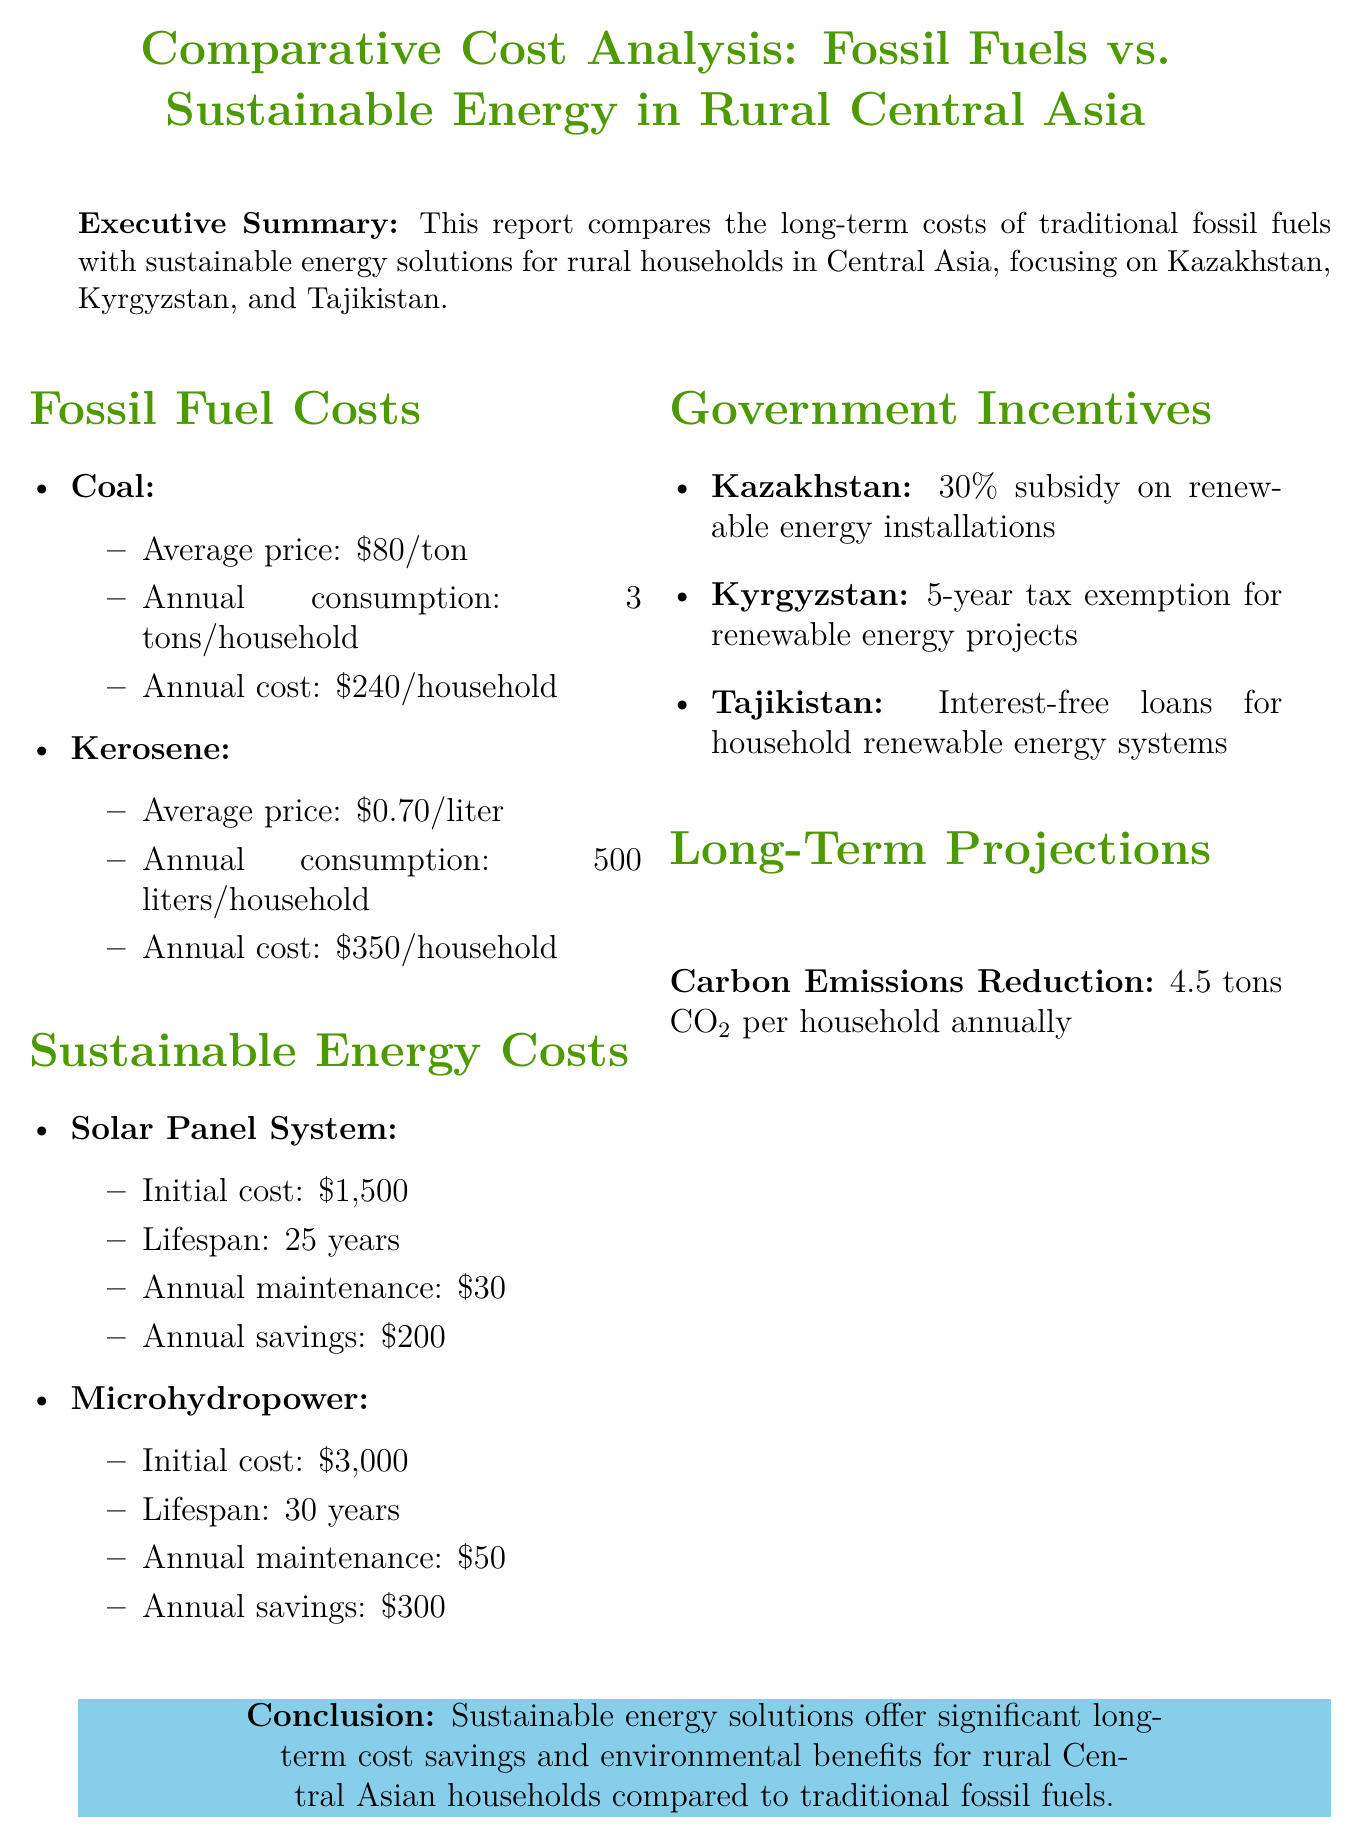What is the average price of coal? The average price of coal is mentioned in the fossil fuel costs section as $80 per ton.
Answer: $80 What is the annual maintenance cost for solar panel systems? The annual maintenance cost for solar panel systems is stated as $30 in the sustainable energy costs section.
Answer: $30 What is the initial installation cost of microhydropower systems? The initial installation cost for microhydropower is specified as $3,000 in the sustainable energy costs section.
Answer: $3,000 How much can households save annually by switching to solar energy? Annual savings when switching to solar energy is noted as $200 in the sustainable energy costs section.
Answer: $200 What is the total 10-year cost predicted for fossil fuels? The report states the total 10-year cost for fossil fuels as $5,900 in the long-term projections section.
Answer: $5,900 What government incentive is available in Kazakhstan? Kazakhstan offers a 30% subsidy on renewable energy installations as indicated in the government incentives section.
Answer: 30% subsidy What is the average lifespan of solar panel systems? The report lists the average lifespan of solar panel systems as 25 years in the sustainable energy costs section.
Answer: 25 years What is the annual carbon emissions reduction per household? The report highlights a carbon emissions reduction of 4.5 tons CO2 per household annually.
Answer: 4.5 tons CO2 What is the conclusion of the report? The conclusion summarizes the benefits of sustainable energy solutions, stating they offer significant long-term cost savings and environmental benefits.
Answer: Significant long-term cost savings and environmental benefits 